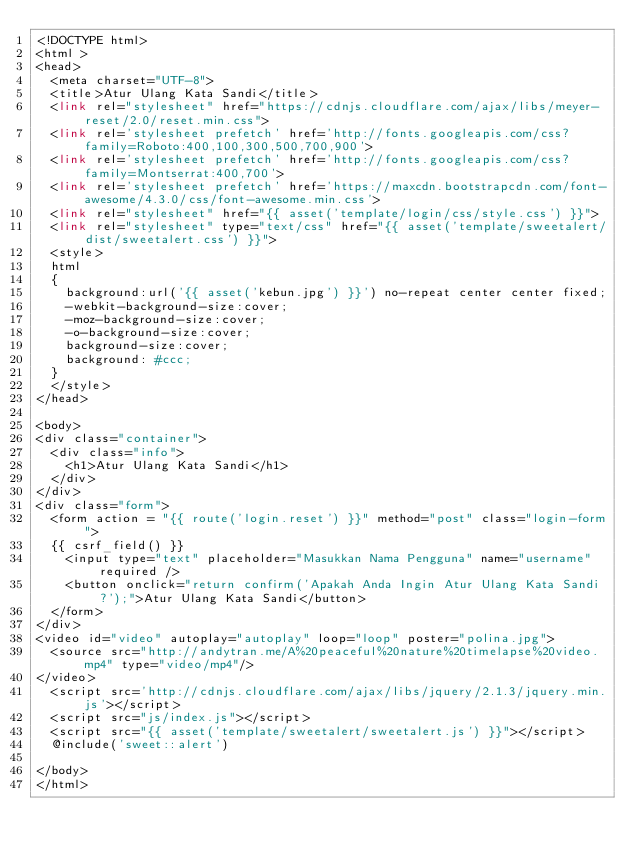Convert code to text. <code><loc_0><loc_0><loc_500><loc_500><_PHP_><!DOCTYPE html>
<html >
<head>
  <meta charset="UTF-8">
  <title>Atur Ulang Kata Sandi</title>
  <link rel="stylesheet" href="https://cdnjs.cloudflare.com/ajax/libs/meyer-reset/2.0/reset.min.css">
  <link rel='stylesheet prefetch' href='http://fonts.googleapis.com/css?family=Roboto:400,100,300,500,700,900'>
  <link rel='stylesheet prefetch' href='http://fonts.googleapis.com/css?family=Montserrat:400,700'>
  <link rel='stylesheet prefetch' href='https://maxcdn.bootstrapcdn.com/font-awesome/4.3.0/css/font-awesome.min.css'>
  <link rel="stylesheet" href="{{ asset('template/login/css/style.css') }}">  
  <link rel="stylesheet" type="text/css" href="{{ asset('template/sweetalert/dist/sweetalert.css') }}">
  <style>
  html
  {
    background:url('{{ asset('kebun.jpg') }}') no-repeat center center fixed;
    -webkit-background-size:cover;
    -moz-background-size:cover;
    -o-background-size:cover;
    background-size:cover;
    background: #ccc;
  }
  </style>
</head>

<body>
<div class="container">
  <div class="info">
    <h1>Atur Ulang Kata Sandi</h1>
  </div>
</div>
<div class="form">
  <form action = "{{ route('login.reset') }}" method="post" class="login-form">
  {{ csrf_field() }}
    <input type="text" placeholder="Masukkan Nama Pengguna" name="username" required />
    <button onclick="return confirm('Apakah Anda Ingin Atur Ulang Kata Sandi?');">Atur Ulang Kata Sandi</button>
  </form>
</div>
<video id="video" autoplay="autoplay" loop="loop" poster="polina.jpg">
  <source src="http://andytran.me/A%20peaceful%20nature%20timelapse%20video.mp4" type="video/mp4"/>
</video>
  <script src='http://cdnjs.cloudflare.com/ajax/libs/jquery/2.1.3/jquery.min.js'></script>
  <script src="js/index.js"></script>
  <script src="{{ asset('template/sweetalert/sweetalert.js') }}"></script>
  @include('sweet::alert')

</body>
</html>
</code> 